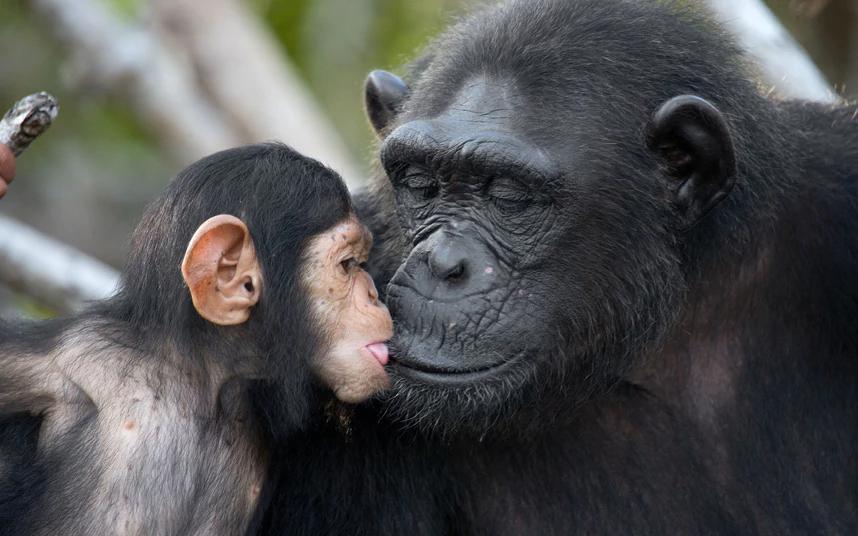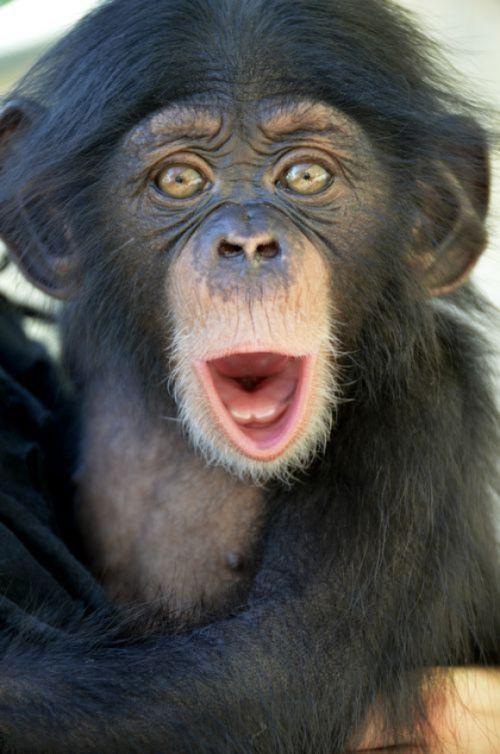The first image is the image on the left, the second image is the image on the right. For the images shown, is this caption "There is at most 1 black monkey with its mouth open." true? Answer yes or no. Yes. The first image is the image on the left, the second image is the image on the right. Given the left and right images, does the statement "one chimp has its mouth open wide" hold true? Answer yes or no. Yes. 